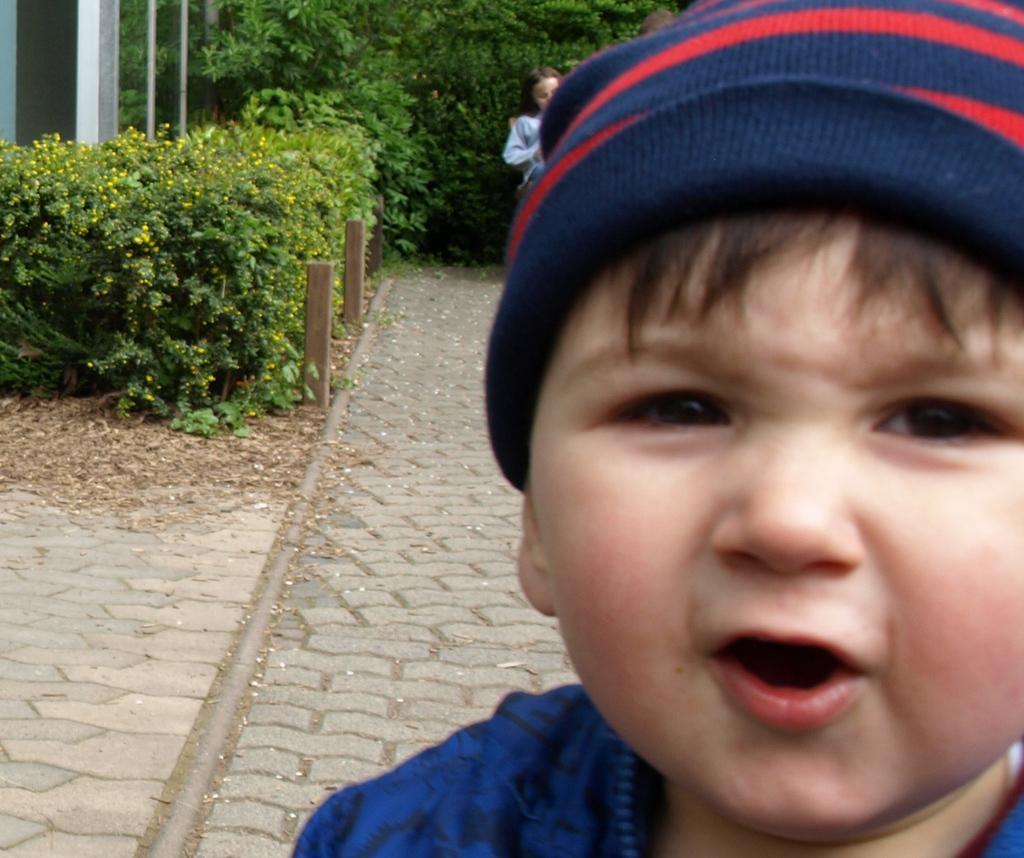In one or two sentences, can you explain what this image depicts? In this picture there is a small boy on the right side of the image and there is a girl behind him and there are bamboos and greenery in the background area of the image. 